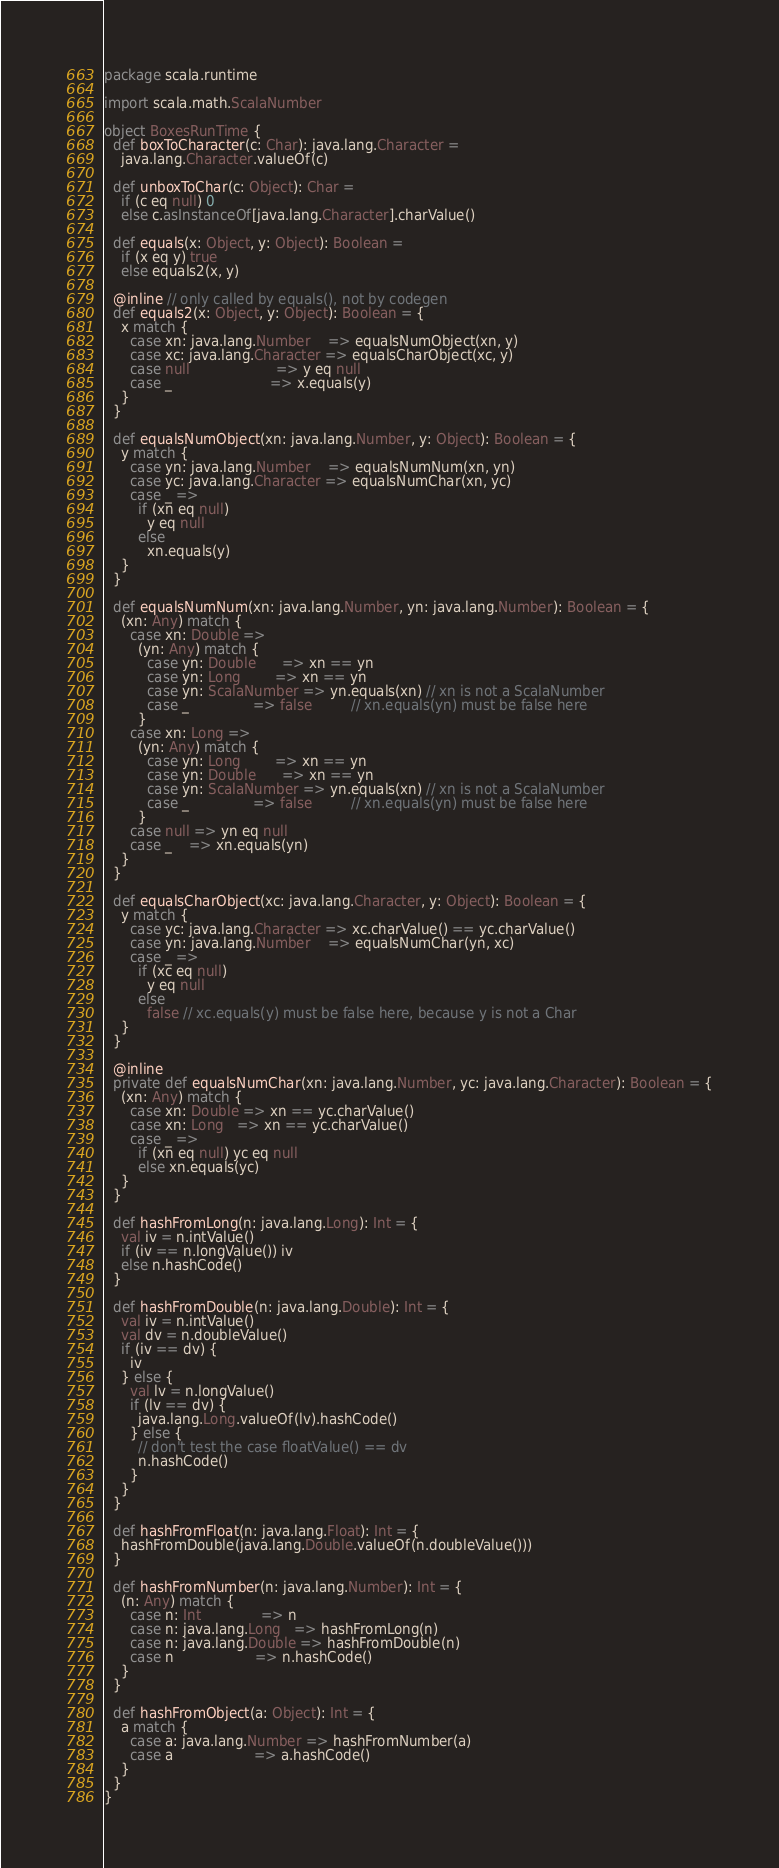Convert code to text. <code><loc_0><loc_0><loc_500><loc_500><_Scala_>package scala.runtime

import scala.math.ScalaNumber

object BoxesRunTime {
  def boxToCharacter(c: Char): java.lang.Character =
    java.lang.Character.valueOf(c)

  def unboxToChar(c: Object): Char =
    if (c eq null) 0
    else c.asInstanceOf[java.lang.Character].charValue()

  def equals(x: Object, y: Object): Boolean =
    if (x eq y) true
    else equals2(x, y)

  @inline // only called by equals(), not by codegen
  def equals2(x: Object, y: Object): Boolean = {
    x match {
      case xn: java.lang.Number    => equalsNumObject(xn, y)
      case xc: java.lang.Character => equalsCharObject(xc, y)
      case null                    => y eq null
      case _                       => x.equals(y)
    }
  }

  def equalsNumObject(xn: java.lang.Number, y: Object): Boolean = {
    y match {
      case yn: java.lang.Number    => equalsNumNum(xn, yn)
      case yc: java.lang.Character => equalsNumChar(xn, yc)
      case _ =>
        if (xn eq null)
          y eq null
        else
          xn.equals(y)
    }
  }

  def equalsNumNum(xn: java.lang.Number, yn: java.lang.Number): Boolean = {
    (xn: Any) match {
      case xn: Double =>
        (yn: Any) match {
          case yn: Double      => xn == yn
          case yn: Long        => xn == yn
          case yn: ScalaNumber => yn.equals(xn) // xn is not a ScalaNumber
          case _               => false         // xn.equals(yn) must be false here
        }
      case xn: Long =>
        (yn: Any) match {
          case yn: Long        => xn == yn
          case yn: Double      => xn == yn
          case yn: ScalaNumber => yn.equals(xn) // xn is not a ScalaNumber
          case _               => false         // xn.equals(yn) must be false here
        }
      case null => yn eq null
      case _    => xn.equals(yn)
    }
  }

  def equalsCharObject(xc: java.lang.Character, y: Object): Boolean = {
    y match {
      case yc: java.lang.Character => xc.charValue() == yc.charValue()
      case yn: java.lang.Number    => equalsNumChar(yn, xc)
      case _ =>
        if (xc eq null)
          y eq null
        else
          false // xc.equals(y) must be false here, because y is not a Char
    }
  }

  @inline
  private def equalsNumChar(xn: java.lang.Number, yc: java.lang.Character): Boolean = {
    (xn: Any) match {
      case xn: Double => xn == yc.charValue()
      case xn: Long   => xn == yc.charValue()
      case _ =>
        if (xn eq null) yc eq null
        else xn.equals(yc)
    }
  }

  def hashFromLong(n: java.lang.Long): Int = {
    val iv = n.intValue()
    if (iv == n.longValue()) iv
    else n.hashCode()
  }

  def hashFromDouble(n: java.lang.Double): Int = {
    val iv = n.intValue()
    val dv = n.doubleValue()
    if (iv == dv) {
      iv
    } else {
      val lv = n.longValue()
      if (lv == dv) {
        java.lang.Long.valueOf(lv).hashCode()
      } else {
        // don't test the case floatValue() == dv
        n.hashCode()
      }
    }
  }

  def hashFromFloat(n: java.lang.Float): Int = {
    hashFromDouble(java.lang.Double.valueOf(n.doubleValue()))
  }

  def hashFromNumber(n: java.lang.Number): Int = {
    (n: Any) match {
      case n: Int              => n
      case n: java.lang.Long   => hashFromLong(n)
      case n: java.lang.Double => hashFromDouble(n)
      case n                   => n.hashCode()
    }
  }

  def hashFromObject(a: Object): Int = {
    a match {
      case a: java.lang.Number => hashFromNumber(a)
      case a                   => a.hashCode()
    }
  }
}
</code> 